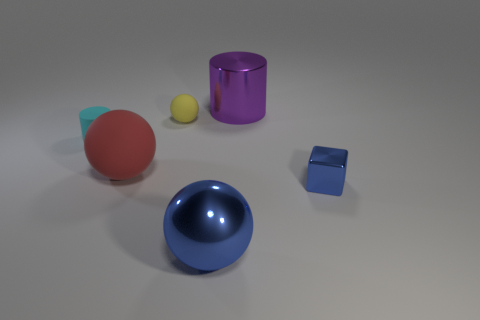Add 1 small blue metal objects. How many objects exist? 7 Subtract all cubes. How many objects are left? 5 Add 6 cyan things. How many cyan things are left? 7 Add 6 brown rubber spheres. How many brown rubber spheres exist? 6 Subtract 1 yellow spheres. How many objects are left? 5 Subtract all yellow cubes. Subtract all red rubber spheres. How many objects are left? 5 